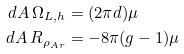<formula> <loc_0><loc_0><loc_500><loc_500>d A \, \Omega _ { L , h } & = ( 2 \pi d ) \mu \\ d A \, R _ { \rho _ { A r } } & = - 8 \pi ( g - 1 ) \mu</formula> 